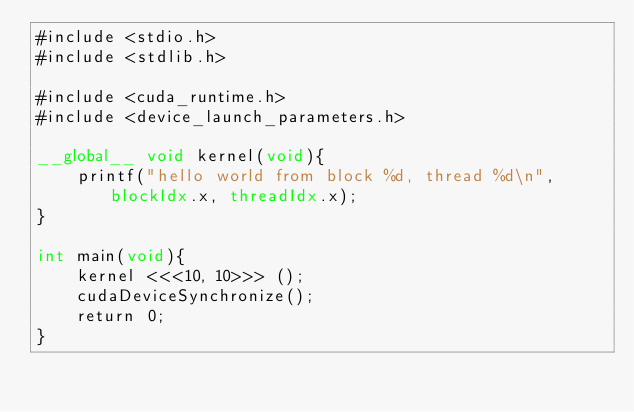Convert code to text. <code><loc_0><loc_0><loc_500><loc_500><_Cuda_>#include <stdio.h>
#include <stdlib.h>

#include <cuda_runtime.h>
#include <device_launch_parameters.h>

__global__ void kernel(void){
	printf("hello world from block %d, thread %d\n", blockIdx.x, threadIdx.x);
}

int main(void){
	kernel <<<10, 10>>> ();
	cudaDeviceSynchronize();
	return 0;
}
</code> 